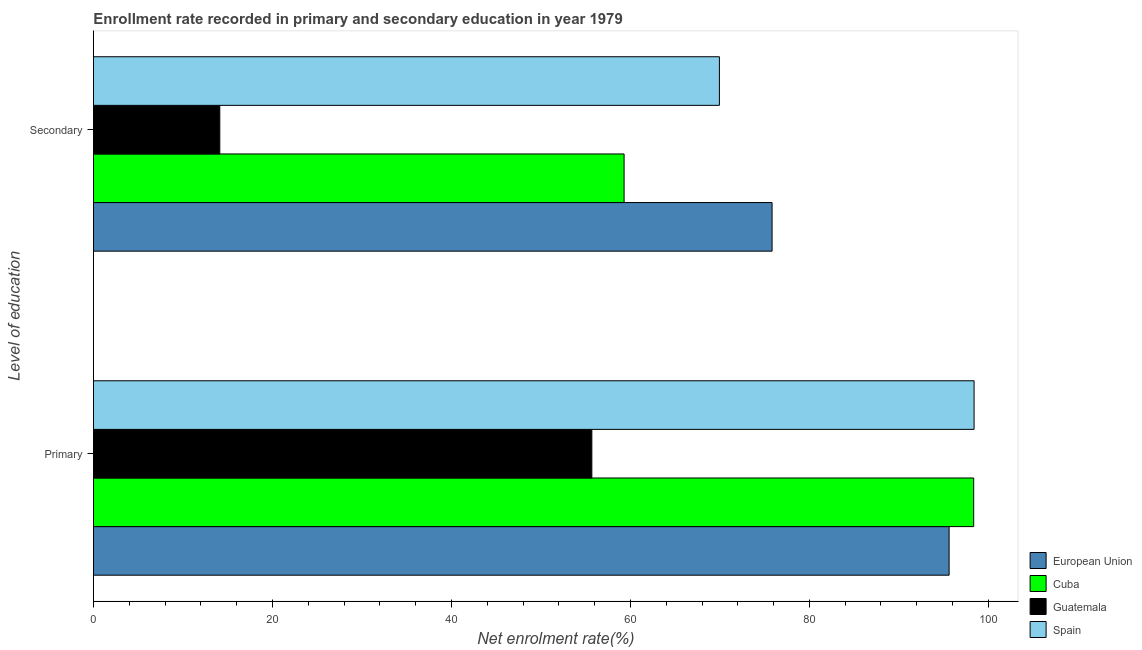Are the number of bars per tick equal to the number of legend labels?
Offer a terse response. Yes. How many bars are there on the 1st tick from the top?
Give a very brief answer. 4. How many bars are there on the 2nd tick from the bottom?
Your answer should be very brief. 4. What is the label of the 2nd group of bars from the top?
Provide a short and direct response. Primary. What is the enrollment rate in secondary education in Cuba?
Keep it short and to the point. 59.29. Across all countries, what is the maximum enrollment rate in secondary education?
Your response must be concise. 75.83. Across all countries, what is the minimum enrollment rate in primary education?
Offer a terse response. 55.69. In which country was the enrollment rate in secondary education maximum?
Keep it short and to the point. European Union. In which country was the enrollment rate in secondary education minimum?
Make the answer very short. Guatemala. What is the total enrollment rate in primary education in the graph?
Provide a short and direct response. 348.06. What is the difference between the enrollment rate in secondary education in Cuba and that in Spain?
Provide a short and direct response. -10.65. What is the difference between the enrollment rate in primary education in European Union and the enrollment rate in secondary education in Cuba?
Give a very brief answer. 36.32. What is the average enrollment rate in secondary education per country?
Offer a very short reply. 54.8. What is the difference between the enrollment rate in primary education and enrollment rate in secondary education in Guatemala?
Your answer should be compact. 41.57. What is the ratio of the enrollment rate in secondary education in Guatemala to that in European Union?
Your answer should be compact. 0.19. Is the enrollment rate in primary education in Guatemala less than that in Spain?
Offer a terse response. Yes. What does the 3rd bar from the top in Secondary represents?
Give a very brief answer. Cuba. How many bars are there?
Offer a terse response. 8. Are all the bars in the graph horizontal?
Offer a very short reply. Yes. Does the graph contain grids?
Your response must be concise. No. Where does the legend appear in the graph?
Offer a very short reply. Bottom right. How are the legend labels stacked?
Keep it short and to the point. Vertical. What is the title of the graph?
Offer a terse response. Enrollment rate recorded in primary and secondary education in year 1979. Does "Lebanon" appear as one of the legend labels in the graph?
Make the answer very short. No. What is the label or title of the X-axis?
Provide a short and direct response. Net enrolment rate(%). What is the label or title of the Y-axis?
Provide a succinct answer. Level of education. What is the Net enrolment rate(%) in European Union in Primary?
Give a very brief answer. 95.61. What is the Net enrolment rate(%) in Cuba in Primary?
Your response must be concise. 98.36. What is the Net enrolment rate(%) of Guatemala in Primary?
Keep it short and to the point. 55.69. What is the Net enrolment rate(%) of Spain in Primary?
Provide a short and direct response. 98.4. What is the Net enrolment rate(%) in European Union in Secondary?
Keep it short and to the point. 75.83. What is the Net enrolment rate(%) in Cuba in Secondary?
Your response must be concise. 59.29. What is the Net enrolment rate(%) in Guatemala in Secondary?
Provide a succinct answer. 14.12. What is the Net enrolment rate(%) in Spain in Secondary?
Make the answer very short. 69.94. Across all Level of education, what is the maximum Net enrolment rate(%) in European Union?
Make the answer very short. 95.61. Across all Level of education, what is the maximum Net enrolment rate(%) of Cuba?
Provide a succinct answer. 98.36. Across all Level of education, what is the maximum Net enrolment rate(%) of Guatemala?
Give a very brief answer. 55.69. Across all Level of education, what is the maximum Net enrolment rate(%) of Spain?
Provide a succinct answer. 98.4. Across all Level of education, what is the minimum Net enrolment rate(%) of European Union?
Ensure brevity in your answer.  75.83. Across all Level of education, what is the minimum Net enrolment rate(%) of Cuba?
Offer a very short reply. 59.29. Across all Level of education, what is the minimum Net enrolment rate(%) of Guatemala?
Your answer should be very brief. 14.12. Across all Level of education, what is the minimum Net enrolment rate(%) in Spain?
Offer a terse response. 69.94. What is the total Net enrolment rate(%) of European Union in the graph?
Give a very brief answer. 171.44. What is the total Net enrolment rate(%) of Cuba in the graph?
Make the answer very short. 157.65. What is the total Net enrolment rate(%) of Guatemala in the graph?
Your answer should be compact. 69.81. What is the total Net enrolment rate(%) of Spain in the graph?
Provide a short and direct response. 168.35. What is the difference between the Net enrolment rate(%) of European Union in Primary and that in Secondary?
Give a very brief answer. 19.78. What is the difference between the Net enrolment rate(%) in Cuba in Primary and that in Secondary?
Your answer should be compact. 39.06. What is the difference between the Net enrolment rate(%) of Guatemala in Primary and that in Secondary?
Make the answer very short. 41.57. What is the difference between the Net enrolment rate(%) of Spain in Primary and that in Secondary?
Provide a succinct answer. 28.46. What is the difference between the Net enrolment rate(%) in European Union in Primary and the Net enrolment rate(%) in Cuba in Secondary?
Provide a succinct answer. 36.32. What is the difference between the Net enrolment rate(%) of European Union in Primary and the Net enrolment rate(%) of Guatemala in Secondary?
Give a very brief answer. 81.5. What is the difference between the Net enrolment rate(%) in European Union in Primary and the Net enrolment rate(%) in Spain in Secondary?
Provide a short and direct response. 25.67. What is the difference between the Net enrolment rate(%) in Cuba in Primary and the Net enrolment rate(%) in Guatemala in Secondary?
Provide a short and direct response. 84.24. What is the difference between the Net enrolment rate(%) of Cuba in Primary and the Net enrolment rate(%) of Spain in Secondary?
Your answer should be compact. 28.42. What is the difference between the Net enrolment rate(%) in Guatemala in Primary and the Net enrolment rate(%) in Spain in Secondary?
Offer a terse response. -14.25. What is the average Net enrolment rate(%) of European Union per Level of education?
Ensure brevity in your answer.  85.72. What is the average Net enrolment rate(%) in Cuba per Level of education?
Keep it short and to the point. 78.83. What is the average Net enrolment rate(%) of Guatemala per Level of education?
Your answer should be compact. 34.9. What is the average Net enrolment rate(%) of Spain per Level of education?
Ensure brevity in your answer.  84.17. What is the difference between the Net enrolment rate(%) of European Union and Net enrolment rate(%) of Cuba in Primary?
Your answer should be very brief. -2.75. What is the difference between the Net enrolment rate(%) of European Union and Net enrolment rate(%) of Guatemala in Primary?
Give a very brief answer. 39.92. What is the difference between the Net enrolment rate(%) in European Union and Net enrolment rate(%) in Spain in Primary?
Make the answer very short. -2.79. What is the difference between the Net enrolment rate(%) of Cuba and Net enrolment rate(%) of Guatemala in Primary?
Ensure brevity in your answer.  42.67. What is the difference between the Net enrolment rate(%) of Cuba and Net enrolment rate(%) of Spain in Primary?
Offer a very short reply. -0.04. What is the difference between the Net enrolment rate(%) of Guatemala and Net enrolment rate(%) of Spain in Primary?
Your answer should be very brief. -42.71. What is the difference between the Net enrolment rate(%) of European Union and Net enrolment rate(%) of Cuba in Secondary?
Your answer should be very brief. 16.54. What is the difference between the Net enrolment rate(%) of European Union and Net enrolment rate(%) of Guatemala in Secondary?
Your answer should be very brief. 61.71. What is the difference between the Net enrolment rate(%) of European Union and Net enrolment rate(%) of Spain in Secondary?
Your answer should be very brief. 5.89. What is the difference between the Net enrolment rate(%) in Cuba and Net enrolment rate(%) in Guatemala in Secondary?
Ensure brevity in your answer.  45.18. What is the difference between the Net enrolment rate(%) of Cuba and Net enrolment rate(%) of Spain in Secondary?
Give a very brief answer. -10.65. What is the difference between the Net enrolment rate(%) in Guatemala and Net enrolment rate(%) in Spain in Secondary?
Provide a short and direct response. -55.83. What is the ratio of the Net enrolment rate(%) of European Union in Primary to that in Secondary?
Your answer should be very brief. 1.26. What is the ratio of the Net enrolment rate(%) in Cuba in Primary to that in Secondary?
Offer a very short reply. 1.66. What is the ratio of the Net enrolment rate(%) of Guatemala in Primary to that in Secondary?
Provide a succinct answer. 3.94. What is the ratio of the Net enrolment rate(%) in Spain in Primary to that in Secondary?
Your response must be concise. 1.41. What is the difference between the highest and the second highest Net enrolment rate(%) in European Union?
Provide a short and direct response. 19.78. What is the difference between the highest and the second highest Net enrolment rate(%) in Cuba?
Your answer should be compact. 39.06. What is the difference between the highest and the second highest Net enrolment rate(%) of Guatemala?
Offer a very short reply. 41.57. What is the difference between the highest and the second highest Net enrolment rate(%) of Spain?
Offer a very short reply. 28.46. What is the difference between the highest and the lowest Net enrolment rate(%) in European Union?
Make the answer very short. 19.78. What is the difference between the highest and the lowest Net enrolment rate(%) in Cuba?
Make the answer very short. 39.06. What is the difference between the highest and the lowest Net enrolment rate(%) of Guatemala?
Keep it short and to the point. 41.57. What is the difference between the highest and the lowest Net enrolment rate(%) of Spain?
Keep it short and to the point. 28.46. 